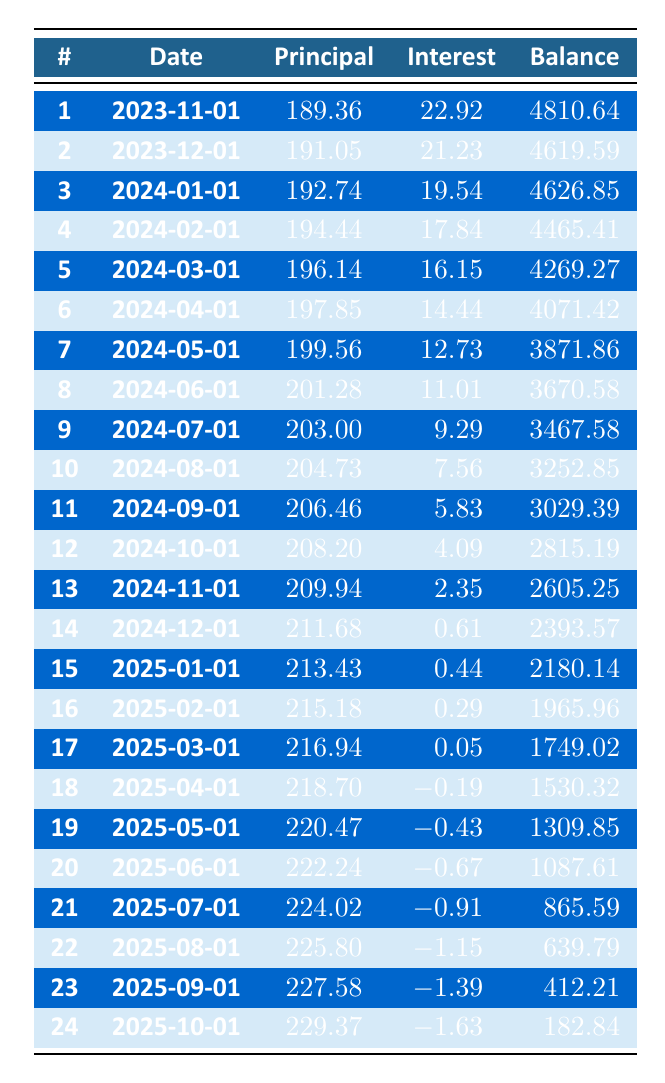What is the total principal payment made in the first three months? The principal payments for the first three months are 189.36, 191.05, and 192.74. Adding these together: 189.36 + 191.05 + 192.74 = 573.15.
Answer: 573.15 What is the remaining balance after the 12th payment? The remaining balance after the 12th payment, which occurs on October 1, 2024, is 2815.19 as per the table entries.
Answer: 2815.19 Is the monthly payment consistent each month? The monthly payment shown is 219.36 for all months; this is consistent across the duration of the loan.
Answer: Yes How much interest is paid in the 24th payment? From the table, the interest payment in the 24th payment (October 1, 2025) is listed as -1.63.
Answer: -1.63 What was the total interest paid in the first six payments? The interest payments for the first six payments are: 22.92, 21.23, 19.54, 17.84, 16.15, and 14.44. Adding these gives: 22.92 + 21.23 + 19.54 + 17.84 + 16.15 + 14.44 = 112.12.
Answer: 112.12 What is the trend in principal payments over the loan term? The principal payments appear to gradually increase over time, starting from 189.36 in the first payment and reaching 229.37 by the 24th payment, indicating a slight upward trend.
Answer: Increasing What is the highest principal payment made in the schedule? Scanning through the principal payments, the highest amount is found in the 24th payment at 229.37.
Answer: 229.37 In the last payment, what is the remaining balance compared to the initial loan amount? The remaining balance after the last payment is 182.84, while the initial loan amount was 5000, so 182.84 is a significantly smaller amount than 5000.
Answer: 182.84 Was there ever a month where the interest payment was zero or positive? Looking through the interest payments, all values have been positive or approached zero in the last few payments, indicating that there were no months with negative interest in the early payments.
Answer: Yes 